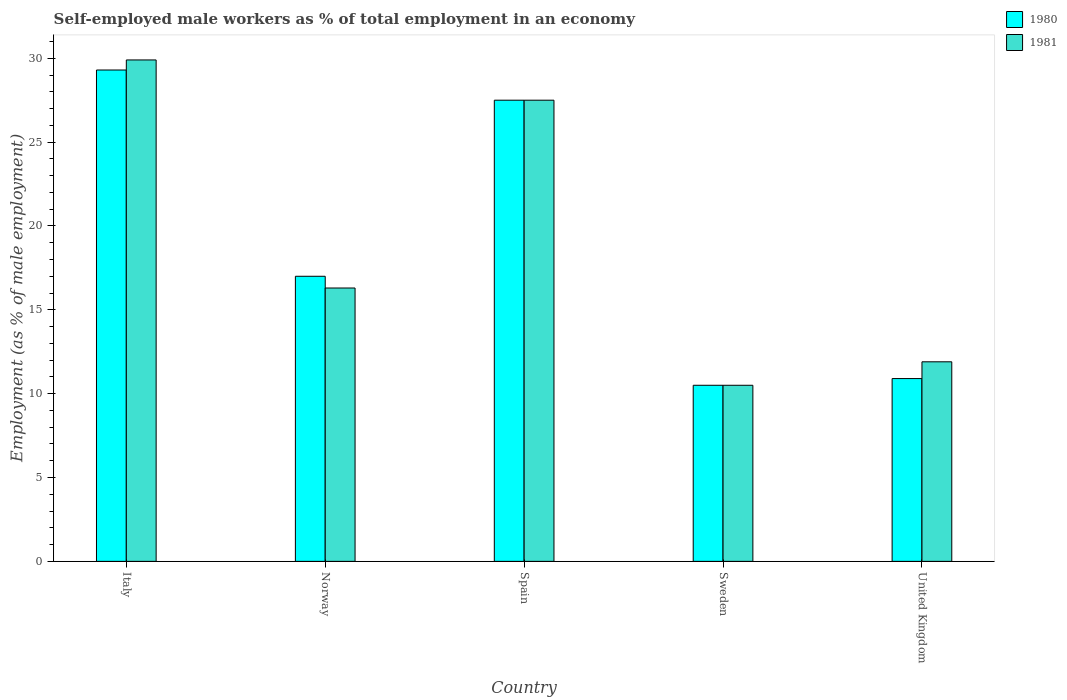How many groups of bars are there?
Your response must be concise. 5. How many bars are there on the 4th tick from the left?
Your response must be concise. 2. What is the percentage of self-employed male workers in 1981 in Italy?
Your response must be concise. 29.9. Across all countries, what is the maximum percentage of self-employed male workers in 1980?
Make the answer very short. 29.3. Across all countries, what is the minimum percentage of self-employed male workers in 1981?
Your answer should be compact. 10.5. In which country was the percentage of self-employed male workers in 1981 minimum?
Give a very brief answer. Sweden. What is the total percentage of self-employed male workers in 1981 in the graph?
Ensure brevity in your answer.  96.1. What is the difference between the percentage of self-employed male workers in 1981 in Norway and that in Sweden?
Keep it short and to the point. 5.8. What is the difference between the percentage of self-employed male workers in 1980 in Norway and the percentage of self-employed male workers in 1981 in United Kingdom?
Ensure brevity in your answer.  5.1. What is the average percentage of self-employed male workers in 1980 per country?
Make the answer very short. 19.04. What is the difference between the percentage of self-employed male workers of/in 1980 and percentage of self-employed male workers of/in 1981 in Spain?
Ensure brevity in your answer.  0. In how many countries, is the percentage of self-employed male workers in 1980 greater than 13 %?
Offer a terse response. 3. What is the ratio of the percentage of self-employed male workers in 1980 in Italy to that in Spain?
Your answer should be compact. 1.07. What is the difference between the highest and the second highest percentage of self-employed male workers in 1981?
Your answer should be compact. -11.2. What is the difference between the highest and the lowest percentage of self-employed male workers in 1980?
Give a very brief answer. 18.8. In how many countries, is the percentage of self-employed male workers in 1980 greater than the average percentage of self-employed male workers in 1980 taken over all countries?
Provide a short and direct response. 2. Is the sum of the percentage of self-employed male workers in 1981 in Norway and Spain greater than the maximum percentage of self-employed male workers in 1980 across all countries?
Provide a short and direct response. Yes. What does the 1st bar from the left in Sweden represents?
Make the answer very short. 1980. What does the 2nd bar from the right in Italy represents?
Offer a terse response. 1980. How many bars are there?
Your answer should be compact. 10. Are all the bars in the graph horizontal?
Offer a very short reply. No. What is the difference between two consecutive major ticks on the Y-axis?
Provide a short and direct response. 5. Are the values on the major ticks of Y-axis written in scientific E-notation?
Offer a terse response. No. Does the graph contain any zero values?
Your answer should be very brief. No. Does the graph contain grids?
Provide a short and direct response. No. How many legend labels are there?
Your answer should be very brief. 2. How are the legend labels stacked?
Your answer should be very brief. Vertical. What is the title of the graph?
Your answer should be compact. Self-employed male workers as % of total employment in an economy. What is the label or title of the Y-axis?
Your answer should be compact. Employment (as % of male employment). What is the Employment (as % of male employment) of 1980 in Italy?
Your answer should be compact. 29.3. What is the Employment (as % of male employment) in 1981 in Italy?
Keep it short and to the point. 29.9. What is the Employment (as % of male employment) in 1980 in Norway?
Give a very brief answer. 17. What is the Employment (as % of male employment) in 1981 in Norway?
Your answer should be compact. 16.3. What is the Employment (as % of male employment) of 1980 in Spain?
Offer a terse response. 27.5. What is the Employment (as % of male employment) in 1980 in United Kingdom?
Provide a succinct answer. 10.9. What is the Employment (as % of male employment) of 1981 in United Kingdom?
Provide a short and direct response. 11.9. Across all countries, what is the maximum Employment (as % of male employment) of 1980?
Ensure brevity in your answer.  29.3. Across all countries, what is the maximum Employment (as % of male employment) in 1981?
Offer a very short reply. 29.9. Across all countries, what is the minimum Employment (as % of male employment) of 1980?
Offer a very short reply. 10.5. Across all countries, what is the minimum Employment (as % of male employment) of 1981?
Provide a short and direct response. 10.5. What is the total Employment (as % of male employment) of 1980 in the graph?
Ensure brevity in your answer.  95.2. What is the total Employment (as % of male employment) of 1981 in the graph?
Offer a very short reply. 96.1. What is the difference between the Employment (as % of male employment) in 1980 in Italy and that in Norway?
Offer a terse response. 12.3. What is the difference between the Employment (as % of male employment) in 1981 in Italy and that in Norway?
Make the answer very short. 13.6. What is the difference between the Employment (as % of male employment) of 1981 in Italy and that in Spain?
Provide a succinct answer. 2.4. What is the difference between the Employment (as % of male employment) of 1980 in Italy and that in Sweden?
Offer a very short reply. 18.8. What is the difference between the Employment (as % of male employment) in 1980 in Italy and that in United Kingdom?
Your response must be concise. 18.4. What is the difference between the Employment (as % of male employment) in 1981 in Italy and that in United Kingdom?
Your response must be concise. 18. What is the difference between the Employment (as % of male employment) of 1981 in Norway and that in Spain?
Ensure brevity in your answer.  -11.2. What is the difference between the Employment (as % of male employment) in 1981 in Norway and that in Sweden?
Your answer should be compact. 5.8. What is the difference between the Employment (as % of male employment) in 1980 in Norway and that in United Kingdom?
Ensure brevity in your answer.  6.1. What is the difference between the Employment (as % of male employment) in 1981 in Spain and that in Sweden?
Keep it short and to the point. 17. What is the difference between the Employment (as % of male employment) in 1980 in Spain and that in United Kingdom?
Ensure brevity in your answer.  16.6. What is the difference between the Employment (as % of male employment) of 1980 in Sweden and that in United Kingdom?
Provide a succinct answer. -0.4. What is the difference between the Employment (as % of male employment) of 1980 in Italy and the Employment (as % of male employment) of 1981 in United Kingdom?
Your answer should be compact. 17.4. What is the difference between the Employment (as % of male employment) of 1980 in Norway and the Employment (as % of male employment) of 1981 in Sweden?
Provide a succinct answer. 6.5. What is the difference between the Employment (as % of male employment) of 1980 in Spain and the Employment (as % of male employment) of 1981 in Sweden?
Ensure brevity in your answer.  17. What is the difference between the Employment (as % of male employment) of 1980 in Spain and the Employment (as % of male employment) of 1981 in United Kingdom?
Provide a succinct answer. 15.6. What is the difference between the Employment (as % of male employment) in 1980 in Sweden and the Employment (as % of male employment) in 1981 in United Kingdom?
Keep it short and to the point. -1.4. What is the average Employment (as % of male employment) of 1980 per country?
Offer a terse response. 19.04. What is the average Employment (as % of male employment) in 1981 per country?
Provide a succinct answer. 19.22. What is the difference between the Employment (as % of male employment) of 1980 and Employment (as % of male employment) of 1981 in Italy?
Provide a succinct answer. -0.6. What is the ratio of the Employment (as % of male employment) of 1980 in Italy to that in Norway?
Offer a very short reply. 1.72. What is the ratio of the Employment (as % of male employment) of 1981 in Italy to that in Norway?
Keep it short and to the point. 1.83. What is the ratio of the Employment (as % of male employment) of 1980 in Italy to that in Spain?
Your response must be concise. 1.07. What is the ratio of the Employment (as % of male employment) in 1981 in Italy to that in Spain?
Your answer should be compact. 1.09. What is the ratio of the Employment (as % of male employment) in 1980 in Italy to that in Sweden?
Your answer should be very brief. 2.79. What is the ratio of the Employment (as % of male employment) in 1981 in Italy to that in Sweden?
Offer a terse response. 2.85. What is the ratio of the Employment (as % of male employment) in 1980 in Italy to that in United Kingdom?
Your response must be concise. 2.69. What is the ratio of the Employment (as % of male employment) of 1981 in Italy to that in United Kingdom?
Provide a succinct answer. 2.51. What is the ratio of the Employment (as % of male employment) in 1980 in Norway to that in Spain?
Your answer should be very brief. 0.62. What is the ratio of the Employment (as % of male employment) in 1981 in Norway to that in Spain?
Offer a terse response. 0.59. What is the ratio of the Employment (as % of male employment) in 1980 in Norway to that in Sweden?
Your response must be concise. 1.62. What is the ratio of the Employment (as % of male employment) in 1981 in Norway to that in Sweden?
Offer a terse response. 1.55. What is the ratio of the Employment (as % of male employment) of 1980 in Norway to that in United Kingdom?
Keep it short and to the point. 1.56. What is the ratio of the Employment (as % of male employment) of 1981 in Norway to that in United Kingdom?
Your response must be concise. 1.37. What is the ratio of the Employment (as % of male employment) of 1980 in Spain to that in Sweden?
Keep it short and to the point. 2.62. What is the ratio of the Employment (as % of male employment) in 1981 in Spain to that in Sweden?
Your answer should be very brief. 2.62. What is the ratio of the Employment (as % of male employment) of 1980 in Spain to that in United Kingdom?
Offer a terse response. 2.52. What is the ratio of the Employment (as % of male employment) in 1981 in Spain to that in United Kingdom?
Provide a short and direct response. 2.31. What is the ratio of the Employment (as % of male employment) of 1980 in Sweden to that in United Kingdom?
Your answer should be compact. 0.96. What is the ratio of the Employment (as % of male employment) of 1981 in Sweden to that in United Kingdom?
Keep it short and to the point. 0.88. What is the difference between the highest and the second highest Employment (as % of male employment) in 1980?
Make the answer very short. 1.8. 